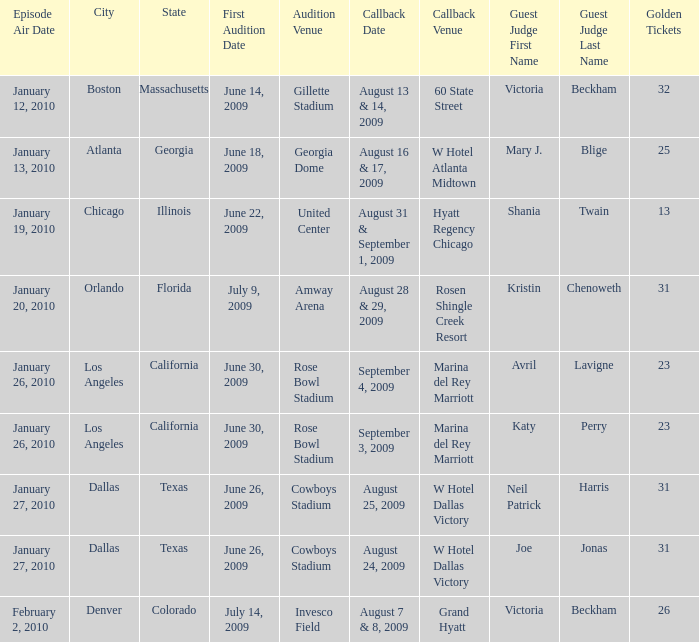Name the callback date for amway arena August 28 & 29, 2009. 